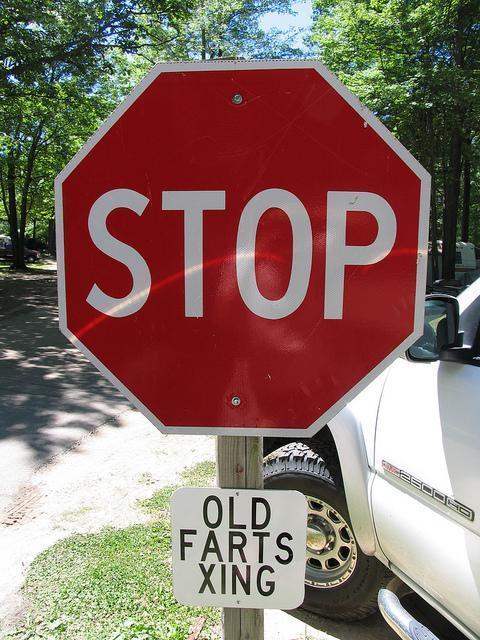How many cars are there?
Give a very brief answer. 1. 